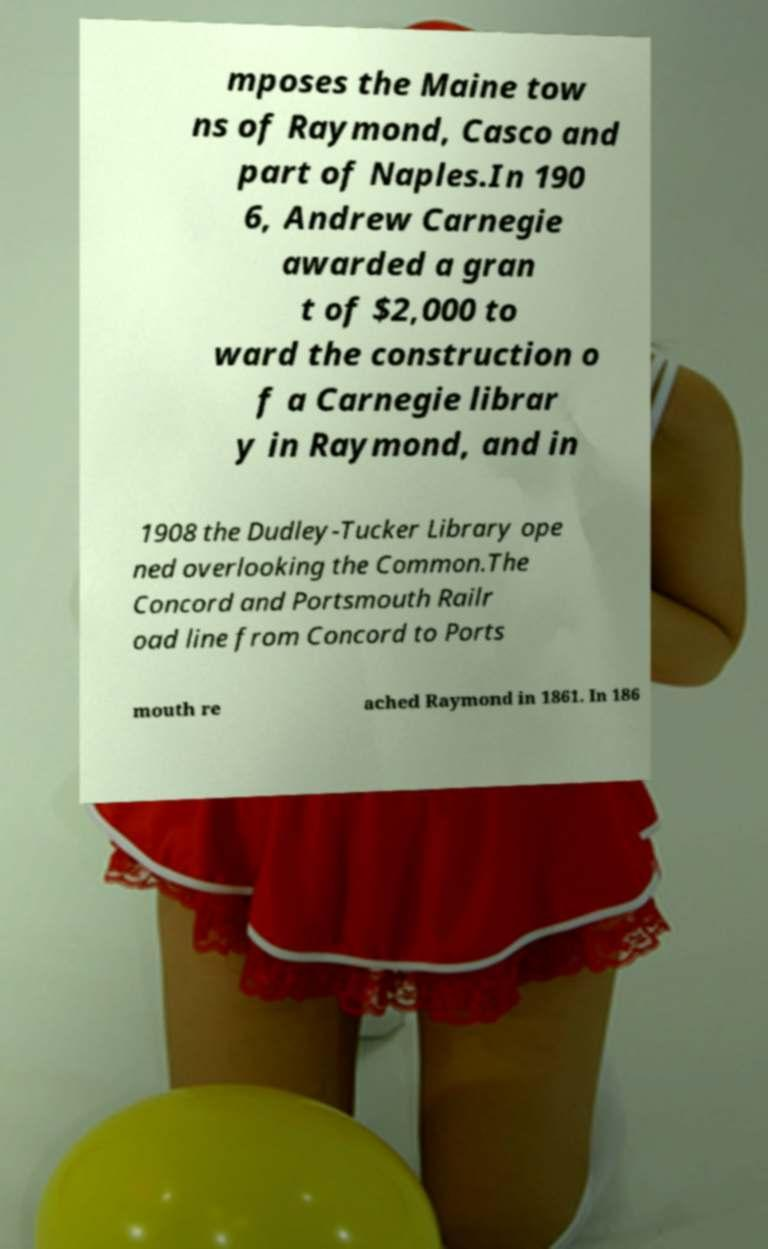Can you read and provide the text displayed in the image?This photo seems to have some interesting text. Can you extract and type it out for me? mposes the Maine tow ns of Raymond, Casco and part of Naples.In 190 6, Andrew Carnegie awarded a gran t of $2,000 to ward the construction o f a Carnegie librar y in Raymond, and in 1908 the Dudley-Tucker Library ope ned overlooking the Common.The Concord and Portsmouth Railr oad line from Concord to Ports mouth re ached Raymond in 1861. In 186 